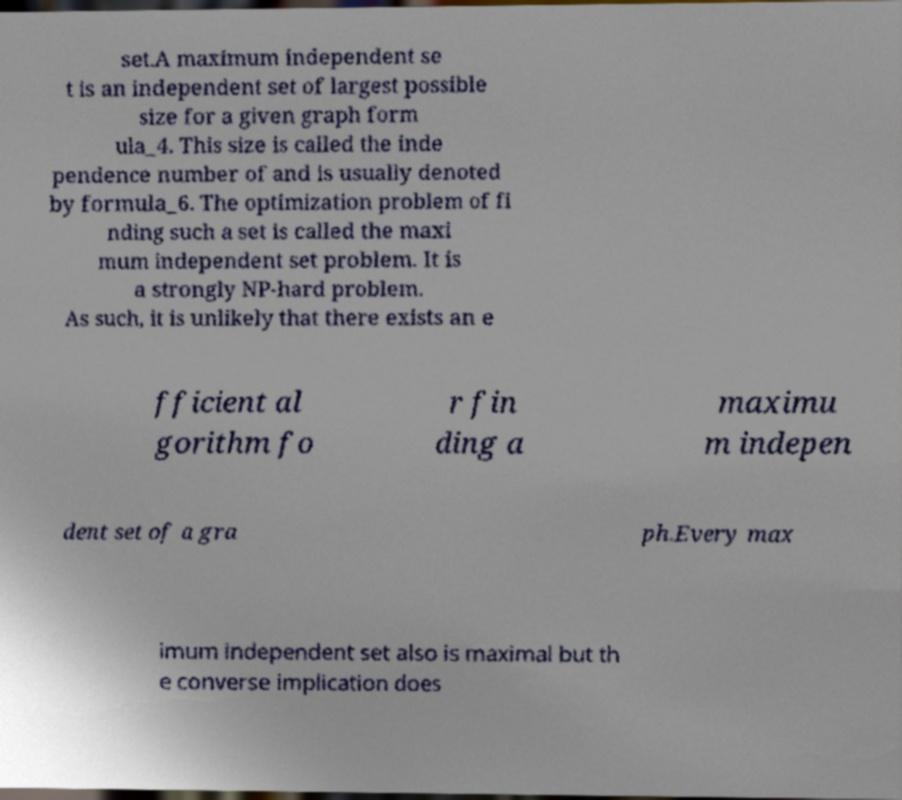Can you accurately transcribe the text from the provided image for me? set.A maximum independent se t is an independent set of largest possible size for a given graph form ula_4. This size is called the inde pendence number of and is usually denoted by formula_6. The optimization problem of fi nding such a set is called the maxi mum independent set problem. It is a strongly NP-hard problem. As such, it is unlikely that there exists an e fficient al gorithm fo r fin ding a maximu m indepen dent set of a gra ph.Every max imum independent set also is maximal but th e converse implication does 